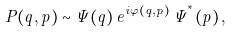<formula> <loc_0><loc_0><loc_500><loc_500>P ( q , p ) \sim \Psi ( q ) \, e ^ { i \varphi ( q , p ) } \, \widetilde { \Psi } ^ { ^ { * } } ( p ) \, ,</formula> 